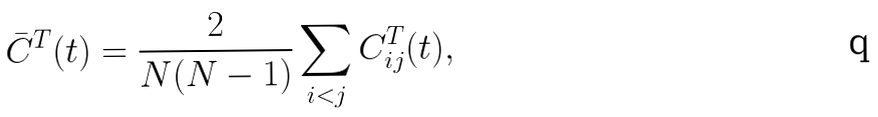Convert formula to latex. <formula><loc_0><loc_0><loc_500><loc_500>\bar { C } ^ { T } ( t ) = \frac { 2 } { N ( N - 1 ) } \sum _ { i < j } C _ { i j } ^ { T } ( t ) ,</formula> 